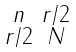<formula> <loc_0><loc_0><loc_500><loc_500>\begin{smallmatrix} n & r / 2 \\ r / 2 & N \end{smallmatrix}</formula> 